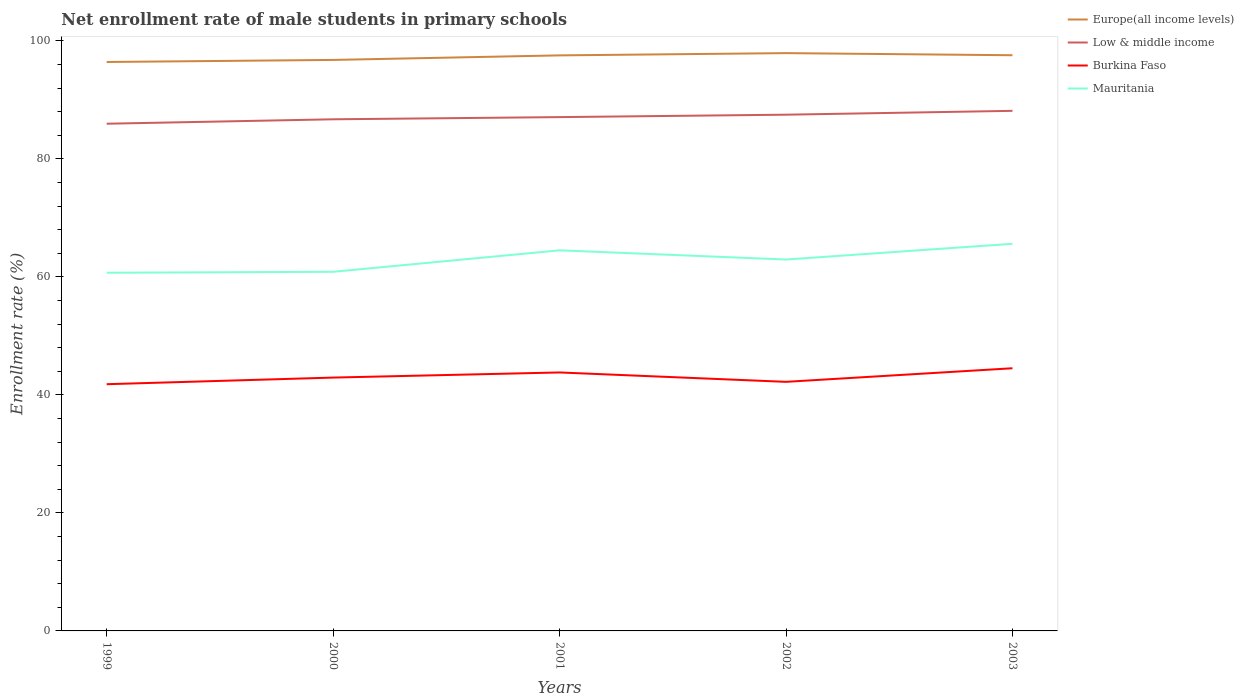Does the line corresponding to Mauritania intersect with the line corresponding to Low & middle income?
Your response must be concise. No. Is the number of lines equal to the number of legend labels?
Give a very brief answer. Yes. Across all years, what is the maximum net enrollment rate of male students in primary schools in Burkina Faso?
Your answer should be very brief. 41.81. What is the total net enrollment rate of male students in primary schools in Low & middle income in the graph?
Offer a terse response. -0.65. What is the difference between the highest and the second highest net enrollment rate of male students in primary schools in Mauritania?
Offer a very short reply. 4.91. What is the difference between two consecutive major ticks on the Y-axis?
Offer a very short reply. 20. Does the graph contain any zero values?
Your answer should be very brief. No. Where does the legend appear in the graph?
Your response must be concise. Top right. How are the legend labels stacked?
Make the answer very short. Vertical. What is the title of the graph?
Offer a very short reply. Net enrollment rate of male students in primary schools. Does "Fragile and conflict affected situations" appear as one of the legend labels in the graph?
Make the answer very short. No. What is the label or title of the X-axis?
Make the answer very short. Years. What is the label or title of the Y-axis?
Keep it short and to the point. Enrollment rate (%). What is the Enrollment rate (%) of Europe(all income levels) in 1999?
Your answer should be very brief. 96.42. What is the Enrollment rate (%) in Low & middle income in 1999?
Keep it short and to the point. 85.96. What is the Enrollment rate (%) in Burkina Faso in 1999?
Your response must be concise. 41.81. What is the Enrollment rate (%) of Mauritania in 1999?
Provide a short and direct response. 60.7. What is the Enrollment rate (%) of Europe(all income levels) in 2000?
Provide a succinct answer. 96.77. What is the Enrollment rate (%) of Low & middle income in 2000?
Provide a short and direct response. 86.71. What is the Enrollment rate (%) in Burkina Faso in 2000?
Offer a very short reply. 42.94. What is the Enrollment rate (%) in Mauritania in 2000?
Make the answer very short. 60.86. What is the Enrollment rate (%) of Europe(all income levels) in 2001?
Provide a short and direct response. 97.54. What is the Enrollment rate (%) in Low & middle income in 2001?
Provide a short and direct response. 87.08. What is the Enrollment rate (%) of Burkina Faso in 2001?
Your answer should be very brief. 43.8. What is the Enrollment rate (%) in Mauritania in 2001?
Make the answer very short. 64.5. What is the Enrollment rate (%) in Europe(all income levels) in 2002?
Your answer should be compact. 97.92. What is the Enrollment rate (%) of Low & middle income in 2002?
Provide a succinct answer. 87.49. What is the Enrollment rate (%) in Burkina Faso in 2002?
Keep it short and to the point. 42.21. What is the Enrollment rate (%) in Mauritania in 2002?
Offer a terse response. 62.94. What is the Enrollment rate (%) in Europe(all income levels) in 2003?
Provide a succinct answer. 97.56. What is the Enrollment rate (%) in Low & middle income in 2003?
Offer a very short reply. 88.14. What is the Enrollment rate (%) in Burkina Faso in 2003?
Your answer should be very brief. 44.52. What is the Enrollment rate (%) in Mauritania in 2003?
Provide a short and direct response. 65.61. Across all years, what is the maximum Enrollment rate (%) in Europe(all income levels)?
Keep it short and to the point. 97.92. Across all years, what is the maximum Enrollment rate (%) in Low & middle income?
Provide a succinct answer. 88.14. Across all years, what is the maximum Enrollment rate (%) in Burkina Faso?
Offer a very short reply. 44.52. Across all years, what is the maximum Enrollment rate (%) in Mauritania?
Ensure brevity in your answer.  65.61. Across all years, what is the minimum Enrollment rate (%) in Europe(all income levels)?
Your answer should be compact. 96.42. Across all years, what is the minimum Enrollment rate (%) in Low & middle income?
Provide a succinct answer. 85.96. Across all years, what is the minimum Enrollment rate (%) of Burkina Faso?
Provide a succinct answer. 41.81. Across all years, what is the minimum Enrollment rate (%) of Mauritania?
Your response must be concise. 60.7. What is the total Enrollment rate (%) of Europe(all income levels) in the graph?
Offer a very short reply. 486.22. What is the total Enrollment rate (%) of Low & middle income in the graph?
Your response must be concise. 435.37. What is the total Enrollment rate (%) of Burkina Faso in the graph?
Offer a terse response. 215.28. What is the total Enrollment rate (%) of Mauritania in the graph?
Ensure brevity in your answer.  314.62. What is the difference between the Enrollment rate (%) in Europe(all income levels) in 1999 and that in 2000?
Ensure brevity in your answer.  -0.35. What is the difference between the Enrollment rate (%) of Low & middle income in 1999 and that in 2000?
Offer a terse response. -0.75. What is the difference between the Enrollment rate (%) of Burkina Faso in 1999 and that in 2000?
Ensure brevity in your answer.  -1.12. What is the difference between the Enrollment rate (%) in Mauritania in 1999 and that in 2000?
Provide a succinct answer. -0.16. What is the difference between the Enrollment rate (%) in Europe(all income levels) in 1999 and that in 2001?
Offer a terse response. -1.12. What is the difference between the Enrollment rate (%) in Low & middle income in 1999 and that in 2001?
Make the answer very short. -1.12. What is the difference between the Enrollment rate (%) of Burkina Faso in 1999 and that in 2001?
Ensure brevity in your answer.  -1.99. What is the difference between the Enrollment rate (%) in Mauritania in 1999 and that in 2001?
Your answer should be compact. -3.8. What is the difference between the Enrollment rate (%) in Europe(all income levels) in 1999 and that in 2002?
Your response must be concise. -1.5. What is the difference between the Enrollment rate (%) of Low & middle income in 1999 and that in 2002?
Offer a terse response. -1.53. What is the difference between the Enrollment rate (%) in Burkina Faso in 1999 and that in 2002?
Offer a terse response. -0.4. What is the difference between the Enrollment rate (%) of Mauritania in 1999 and that in 2002?
Offer a very short reply. -2.24. What is the difference between the Enrollment rate (%) of Europe(all income levels) in 1999 and that in 2003?
Offer a terse response. -1.14. What is the difference between the Enrollment rate (%) in Low & middle income in 1999 and that in 2003?
Provide a succinct answer. -2.18. What is the difference between the Enrollment rate (%) in Burkina Faso in 1999 and that in 2003?
Provide a short and direct response. -2.7. What is the difference between the Enrollment rate (%) of Mauritania in 1999 and that in 2003?
Keep it short and to the point. -4.91. What is the difference between the Enrollment rate (%) in Europe(all income levels) in 2000 and that in 2001?
Offer a very short reply. -0.77. What is the difference between the Enrollment rate (%) in Low & middle income in 2000 and that in 2001?
Offer a very short reply. -0.37. What is the difference between the Enrollment rate (%) in Burkina Faso in 2000 and that in 2001?
Give a very brief answer. -0.87. What is the difference between the Enrollment rate (%) of Mauritania in 2000 and that in 2001?
Keep it short and to the point. -3.64. What is the difference between the Enrollment rate (%) of Europe(all income levels) in 2000 and that in 2002?
Give a very brief answer. -1.15. What is the difference between the Enrollment rate (%) in Low & middle income in 2000 and that in 2002?
Provide a succinct answer. -0.78. What is the difference between the Enrollment rate (%) of Burkina Faso in 2000 and that in 2002?
Ensure brevity in your answer.  0.72. What is the difference between the Enrollment rate (%) of Mauritania in 2000 and that in 2002?
Give a very brief answer. -2.08. What is the difference between the Enrollment rate (%) in Europe(all income levels) in 2000 and that in 2003?
Ensure brevity in your answer.  -0.79. What is the difference between the Enrollment rate (%) of Low & middle income in 2000 and that in 2003?
Provide a short and direct response. -1.43. What is the difference between the Enrollment rate (%) in Burkina Faso in 2000 and that in 2003?
Provide a short and direct response. -1.58. What is the difference between the Enrollment rate (%) of Mauritania in 2000 and that in 2003?
Your response must be concise. -4.75. What is the difference between the Enrollment rate (%) in Europe(all income levels) in 2001 and that in 2002?
Your response must be concise. -0.38. What is the difference between the Enrollment rate (%) of Low & middle income in 2001 and that in 2002?
Keep it short and to the point. -0.41. What is the difference between the Enrollment rate (%) in Burkina Faso in 2001 and that in 2002?
Your answer should be very brief. 1.59. What is the difference between the Enrollment rate (%) in Mauritania in 2001 and that in 2002?
Make the answer very short. 1.56. What is the difference between the Enrollment rate (%) in Europe(all income levels) in 2001 and that in 2003?
Your response must be concise. -0.02. What is the difference between the Enrollment rate (%) of Low & middle income in 2001 and that in 2003?
Your answer should be compact. -1.06. What is the difference between the Enrollment rate (%) in Burkina Faso in 2001 and that in 2003?
Offer a very short reply. -0.71. What is the difference between the Enrollment rate (%) of Mauritania in 2001 and that in 2003?
Keep it short and to the point. -1.11. What is the difference between the Enrollment rate (%) of Europe(all income levels) in 2002 and that in 2003?
Provide a short and direct response. 0.36. What is the difference between the Enrollment rate (%) in Low & middle income in 2002 and that in 2003?
Your answer should be very brief. -0.65. What is the difference between the Enrollment rate (%) of Burkina Faso in 2002 and that in 2003?
Offer a terse response. -2.3. What is the difference between the Enrollment rate (%) of Mauritania in 2002 and that in 2003?
Provide a succinct answer. -2.67. What is the difference between the Enrollment rate (%) of Europe(all income levels) in 1999 and the Enrollment rate (%) of Low & middle income in 2000?
Offer a very short reply. 9.71. What is the difference between the Enrollment rate (%) in Europe(all income levels) in 1999 and the Enrollment rate (%) in Burkina Faso in 2000?
Make the answer very short. 53.49. What is the difference between the Enrollment rate (%) of Europe(all income levels) in 1999 and the Enrollment rate (%) of Mauritania in 2000?
Provide a short and direct response. 35.56. What is the difference between the Enrollment rate (%) in Low & middle income in 1999 and the Enrollment rate (%) in Burkina Faso in 2000?
Offer a very short reply. 43.02. What is the difference between the Enrollment rate (%) in Low & middle income in 1999 and the Enrollment rate (%) in Mauritania in 2000?
Your response must be concise. 25.1. What is the difference between the Enrollment rate (%) of Burkina Faso in 1999 and the Enrollment rate (%) of Mauritania in 2000?
Keep it short and to the point. -19.05. What is the difference between the Enrollment rate (%) in Europe(all income levels) in 1999 and the Enrollment rate (%) in Low & middle income in 2001?
Provide a succinct answer. 9.34. What is the difference between the Enrollment rate (%) in Europe(all income levels) in 1999 and the Enrollment rate (%) in Burkina Faso in 2001?
Make the answer very short. 52.62. What is the difference between the Enrollment rate (%) of Europe(all income levels) in 1999 and the Enrollment rate (%) of Mauritania in 2001?
Provide a short and direct response. 31.92. What is the difference between the Enrollment rate (%) in Low & middle income in 1999 and the Enrollment rate (%) in Burkina Faso in 2001?
Offer a very short reply. 42.15. What is the difference between the Enrollment rate (%) of Low & middle income in 1999 and the Enrollment rate (%) of Mauritania in 2001?
Your answer should be very brief. 21.46. What is the difference between the Enrollment rate (%) of Burkina Faso in 1999 and the Enrollment rate (%) of Mauritania in 2001?
Offer a terse response. -22.69. What is the difference between the Enrollment rate (%) of Europe(all income levels) in 1999 and the Enrollment rate (%) of Low & middle income in 2002?
Ensure brevity in your answer.  8.93. What is the difference between the Enrollment rate (%) of Europe(all income levels) in 1999 and the Enrollment rate (%) of Burkina Faso in 2002?
Give a very brief answer. 54.21. What is the difference between the Enrollment rate (%) of Europe(all income levels) in 1999 and the Enrollment rate (%) of Mauritania in 2002?
Make the answer very short. 33.48. What is the difference between the Enrollment rate (%) of Low & middle income in 1999 and the Enrollment rate (%) of Burkina Faso in 2002?
Make the answer very short. 43.74. What is the difference between the Enrollment rate (%) of Low & middle income in 1999 and the Enrollment rate (%) of Mauritania in 2002?
Keep it short and to the point. 23.02. What is the difference between the Enrollment rate (%) of Burkina Faso in 1999 and the Enrollment rate (%) of Mauritania in 2002?
Your response must be concise. -21.13. What is the difference between the Enrollment rate (%) in Europe(all income levels) in 1999 and the Enrollment rate (%) in Low & middle income in 2003?
Give a very brief answer. 8.28. What is the difference between the Enrollment rate (%) of Europe(all income levels) in 1999 and the Enrollment rate (%) of Burkina Faso in 2003?
Ensure brevity in your answer.  51.91. What is the difference between the Enrollment rate (%) of Europe(all income levels) in 1999 and the Enrollment rate (%) of Mauritania in 2003?
Offer a very short reply. 30.81. What is the difference between the Enrollment rate (%) of Low & middle income in 1999 and the Enrollment rate (%) of Burkina Faso in 2003?
Keep it short and to the point. 41.44. What is the difference between the Enrollment rate (%) of Low & middle income in 1999 and the Enrollment rate (%) of Mauritania in 2003?
Offer a very short reply. 20.35. What is the difference between the Enrollment rate (%) of Burkina Faso in 1999 and the Enrollment rate (%) of Mauritania in 2003?
Keep it short and to the point. -23.8. What is the difference between the Enrollment rate (%) in Europe(all income levels) in 2000 and the Enrollment rate (%) in Low & middle income in 2001?
Ensure brevity in your answer.  9.69. What is the difference between the Enrollment rate (%) of Europe(all income levels) in 2000 and the Enrollment rate (%) of Burkina Faso in 2001?
Your answer should be very brief. 52.97. What is the difference between the Enrollment rate (%) in Europe(all income levels) in 2000 and the Enrollment rate (%) in Mauritania in 2001?
Offer a terse response. 32.27. What is the difference between the Enrollment rate (%) of Low & middle income in 2000 and the Enrollment rate (%) of Burkina Faso in 2001?
Provide a succinct answer. 42.9. What is the difference between the Enrollment rate (%) of Low & middle income in 2000 and the Enrollment rate (%) of Mauritania in 2001?
Ensure brevity in your answer.  22.21. What is the difference between the Enrollment rate (%) in Burkina Faso in 2000 and the Enrollment rate (%) in Mauritania in 2001?
Your response must be concise. -21.56. What is the difference between the Enrollment rate (%) of Europe(all income levels) in 2000 and the Enrollment rate (%) of Low & middle income in 2002?
Give a very brief answer. 9.28. What is the difference between the Enrollment rate (%) of Europe(all income levels) in 2000 and the Enrollment rate (%) of Burkina Faso in 2002?
Your answer should be very brief. 54.56. What is the difference between the Enrollment rate (%) of Europe(all income levels) in 2000 and the Enrollment rate (%) of Mauritania in 2002?
Offer a terse response. 33.83. What is the difference between the Enrollment rate (%) of Low & middle income in 2000 and the Enrollment rate (%) of Burkina Faso in 2002?
Provide a succinct answer. 44.49. What is the difference between the Enrollment rate (%) of Low & middle income in 2000 and the Enrollment rate (%) of Mauritania in 2002?
Offer a very short reply. 23.76. What is the difference between the Enrollment rate (%) of Burkina Faso in 2000 and the Enrollment rate (%) of Mauritania in 2002?
Provide a succinct answer. -20.01. What is the difference between the Enrollment rate (%) in Europe(all income levels) in 2000 and the Enrollment rate (%) in Low & middle income in 2003?
Keep it short and to the point. 8.63. What is the difference between the Enrollment rate (%) in Europe(all income levels) in 2000 and the Enrollment rate (%) in Burkina Faso in 2003?
Offer a terse response. 52.25. What is the difference between the Enrollment rate (%) in Europe(all income levels) in 2000 and the Enrollment rate (%) in Mauritania in 2003?
Provide a succinct answer. 31.16. What is the difference between the Enrollment rate (%) of Low & middle income in 2000 and the Enrollment rate (%) of Burkina Faso in 2003?
Keep it short and to the point. 42.19. What is the difference between the Enrollment rate (%) of Low & middle income in 2000 and the Enrollment rate (%) of Mauritania in 2003?
Give a very brief answer. 21.1. What is the difference between the Enrollment rate (%) in Burkina Faso in 2000 and the Enrollment rate (%) in Mauritania in 2003?
Your answer should be very brief. -22.68. What is the difference between the Enrollment rate (%) in Europe(all income levels) in 2001 and the Enrollment rate (%) in Low & middle income in 2002?
Your answer should be very brief. 10.05. What is the difference between the Enrollment rate (%) in Europe(all income levels) in 2001 and the Enrollment rate (%) in Burkina Faso in 2002?
Provide a succinct answer. 55.33. What is the difference between the Enrollment rate (%) in Europe(all income levels) in 2001 and the Enrollment rate (%) in Mauritania in 2002?
Give a very brief answer. 34.6. What is the difference between the Enrollment rate (%) in Low & middle income in 2001 and the Enrollment rate (%) in Burkina Faso in 2002?
Offer a terse response. 44.87. What is the difference between the Enrollment rate (%) in Low & middle income in 2001 and the Enrollment rate (%) in Mauritania in 2002?
Keep it short and to the point. 24.14. What is the difference between the Enrollment rate (%) of Burkina Faso in 2001 and the Enrollment rate (%) of Mauritania in 2002?
Ensure brevity in your answer.  -19.14. What is the difference between the Enrollment rate (%) in Europe(all income levels) in 2001 and the Enrollment rate (%) in Low & middle income in 2003?
Your response must be concise. 9.4. What is the difference between the Enrollment rate (%) in Europe(all income levels) in 2001 and the Enrollment rate (%) in Burkina Faso in 2003?
Give a very brief answer. 53.03. What is the difference between the Enrollment rate (%) in Europe(all income levels) in 2001 and the Enrollment rate (%) in Mauritania in 2003?
Your answer should be compact. 31.93. What is the difference between the Enrollment rate (%) in Low & middle income in 2001 and the Enrollment rate (%) in Burkina Faso in 2003?
Provide a succinct answer. 42.56. What is the difference between the Enrollment rate (%) of Low & middle income in 2001 and the Enrollment rate (%) of Mauritania in 2003?
Keep it short and to the point. 21.47. What is the difference between the Enrollment rate (%) in Burkina Faso in 2001 and the Enrollment rate (%) in Mauritania in 2003?
Provide a short and direct response. -21.81. What is the difference between the Enrollment rate (%) of Europe(all income levels) in 2002 and the Enrollment rate (%) of Low & middle income in 2003?
Give a very brief answer. 9.78. What is the difference between the Enrollment rate (%) of Europe(all income levels) in 2002 and the Enrollment rate (%) of Burkina Faso in 2003?
Your response must be concise. 53.41. What is the difference between the Enrollment rate (%) of Europe(all income levels) in 2002 and the Enrollment rate (%) of Mauritania in 2003?
Provide a short and direct response. 32.31. What is the difference between the Enrollment rate (%) of Low & middle income in 2002 and the Enrollment rate (%) of Burkina Faso in 2003?
Provide a succinct answer. 42.97. What is the difference between the Enrollment rate (%) of Low & middle income in 2002 and the Enrollment rate (%) of Mauritania in 2003?
Your response must be concise. 21.88. What is the difference between the Enrollment rate (%) in Burkina Faso in 2002 and the Enrollment rate (%) in Mauritania in 2003?
Offer a very short reply. -23.4. What is the average Enrollment rate (%) in Europe(all income levels) per year?
Your response must be concise. 97.24. What is the average Enrollment rate (%) of Low & middle income per year?
Provide a short and direct response. 87.07. What is the average Enrollment rate (%) in Burkina Faso per year?
Your answer should be very brief. 43.06. What is the average Enrollment rate (%) of Mauritania per year?
Keep it short and to the point. 62.92. In the year 1999, what is the difference between the Enrollment rate (%) in Europe(all income levels) and Enrollment rate (%) in Low & middle income?
Offer a terse response. 10.46. In the year 1999, what is the difference between the Enrollment rate (%) of Europe(all income levels) and Enrollment rate (%) of Burkina Faso?
Your answer should be very brief. 54.61. In the year 1999, what is the difference between the Enrollment rate (%) of Europe(all income levels) and Enrollment rate (%) of Mauritania?
Your response must be concise. 35.72. In the year 1999, what is the difference between the Enrollment rate (%) in Low & middle income and Enrollment rate (%) in Burkina Faso?
Your answer should be very brief. 44.14. In the year 1999, what is the difference between the Enrollment rate (%) in Low & middle income and Enrollment rate (%) in Mauritania?
Your answer should be very brief. 25.25. In the year 1999, what is the difference between the Enrollment rate (%) of Burkina Faso and Enrollment rate (%) of Mauritania?
Provide a short and direct response. -18.89. In the year 2000, what is the difference between the Enrollment rate (%) of Europe(all income levels) and Enrollment rate (%) of Low & middle income?
Your response must be concise. 10.06. In the year 2000, what is the difference between the Enrollment rate (%) of Europe(all income levels) and Enrollment rate (%) of Burkina Faso?
Provide a short and direct response. 53.83. In the year 2000, what is the difference between the Enrollment rate (%) of Europe(all income levels) and Enrollment rate (%) of Mauritania?
Your response must be concise. 35.91. In the year 2000, what is the difference between the Enrollment rate (%) of Low & middle income and Enrollment rate (%) of Burkina Faso?
Keep it short and to the point. 43.77. In the year 2000, what is the difference between the Enrollment rate (%) in Low & middle income and Enrollment rate (%) in Mauritania?
Give a very brief answer. 25.84. In the year 2000, what is the difference between the Enrollment rate (%) of Burkina Faso and Enrollment rate (%) of Mauritania?
Your answer should be very brief. -17.93. In the year 2001, what is the difference between the Enrollment rate (%) of Europe(all income levels) and Enrollment rate (%) of Low & middle income?
Your answer should be very brief. 10.46. In the year 2001, what is the difference between the Enrollment rate (%) in Europe(all income levels) and Enrollment rate (%) in Burkina Faso?
Give a very brief answer. 53.74. In the year 2001, what is the difference between the Enrollment rate (%) in Europe(all income levels) and Enrollment rate (%) in Mauritania?
Your answer should be very brief. 33.04. In the year 2001, what is the difference between the Enrollment rate (%) of Low & middle income and Enrollment rate (%) of Burkina Faso?
Your response must be concise. 43.27. In the year 2001, what is the difference between the Enrollment rate (%) in Low & middle income and Enrollment rate (%) in Mauritania?
Give a very brief answer. 22.58. In the year 2001, what is the difference between the Enrollment rate (%) of Burkina Faso and Enrollment rate (%) of Mauritania?
Keep it short and to the point. -20.7. In the year 2002, what is the difference between the Enrollment rate (%) of Europe(all income levels) and Enrollment rate (%) of Low & middle income?
Offer a very short reply. 10.43. In the year 2002, what is the difference between the Enrollment rate (%) in Europe(all income levels) and Enrollment rate (%) in Burkina Faso?
Provide a succinct answer. 55.71. In the year 2002, what is the difference between the Enrollment rate (%) in Europe(all income levels) and Enrollment rate (%) in Mauritania?
Provide a succinct answer. 34.98. In the year 2002, what is the difference between the Enrollment rate (%) in Low & middle income and Enrollment rate (%) in Burkina Faso?
Ensure brevity in your answer.  45.27. In the year 2002, what is the difference between the Enrollment rate (%) in Low & middle income and Enrollment rate (%) in Mauritania?
Make the answer very short. 24.55. In the year 2002, what is the difference between the Enrollment rate (%) in Burkina Faso and Enrollment rate (%) in Mauritania?
Provide a succinct answer. -20.73. In the year 2003, what is the difference between the Enrollment rate (%) in Europe(all income levels) and Enrollment rate (%) in Low & middle income?
Provide a succinct answer. 9.42. In the year 2003, what is the difference between the Enrollment rate (%) of Europe(all income levels) and Enrollment rate (%) of Burkina Faso?
Provide a succinct answer. 53.05. In the year 2003, what is the difference between the Enrollment rate (%) in Europe(all income levels) and Enrollment rate (%) in Mauritania?
Give a very brief answer. 31.95. In the year 2003, what is the difference between the Enrollment rate (%) in Low & middle income and Enrollment rate (%) in Burkina Faso?
Make the answer very short. 43.63. In the year 2003, what is the difference between the Enrollment rate (%) in Low & middle income and Enrollment rate (%) in Mauritania?
Offer a very short reply. 22.53. In the year 2003, what is the difference between the Enrollment rate (%) in Burkina Faso and Enrollment rate (%) in Mauritania?
Offer a terse response. -21.09. What is the ratio of the Enrollment rate (%) in Low & middle income in 1999 to that in 2000?
Ensure brevity in your answer.  0.99. What is the ratio of the Enrollment rate (%) of Burkina Faso in 1999 to that in 2000?
Provide a succinct answer. 0.97. What is the ratio of the Enrollment rate (%) in Europe(all income levels) in 1999 to that in 2001?
Keep it short and to the point. 0.99. What is the ratio of the Enrollment rate (%) in Low & middle income in 1999 to that in 2001?
Ensure brevity in your answer.  0.99. What is the ratio of the Enrollment rate (%) in Burkina Faso in 1999 to that in 2001?
Offer a very short reply. 0.95. What is the ratio of the Enrollment rate (%) in Mauritania in 1999 to that in 2001?
Your answer should be compact. 0.94. What is the ratio of the Enrollment rate (%) of Europe(all income levels) in 1999 to that in 2002?
Keep it short and to the point. 0.98. What is the ratio of the Enrollment rate (%) of Low & middle income in 1999 to that in 2002?
Offer a very short reply. 0.98. What is the ratio of the Enrollment rate (%) of Mauritania in 1999 to that in 2002?
Your answer should be compact. 0.96. What is the ratio of the Enrollment rate (%) in Europe(all income levels) in 1999 to that in 2003?
Offer a terse response. 0.99. What is the ratio of the Enrollment rate (%) of Low & middle income in 1999 to that in 2003?
Make the answer very short. 0.98. What is the ratio of the Enrollment rate (%) of Burkina Faso in 1999 to that in 2003?
Your response must be concise. 0.94. What is the ratio of the Enrollment rate (%) in Mauritania in 1999 to that in 2003?
Provide a succinct answer. 0.93. What is the ratio of the Enrollment rate (%) of Low & middle income in 2000 to that in 2001?
Give a very brief answer. 1. What is the ratio of the Enrollment rate (%) in Burkina Faso in 2000 to that in 2001?
Offer a very short reply. 0.98. What is the ratio of the Enrollment rate (%) of Mauritania in 2000 to that in 2001?
Your answer should be compact. 0.94. What is the ratio of the Enrollment rate (%) in Burkina Faso in 2000 to that in 2002?
Provide a short and direct response. 1.02. What is the ratio of the Enrollment rate (%) of Europe(all income levels) in 2000 to that in 2003?
Offer a terse response. 0.99. What is the ratio of the Enrollment rate (%) of Low & middle income in 2000 to that in 2003?
Make the answer very short. 0.98. What is the ratio of the Enrollment rate (%) in Burkina Faso in 2000 to that in 2003?
Make the answer very short. 0.96. What is the ratio of the Enrollment rate (%) in Mauritania in 2000 to that in 2003?
Provide a short and direct response. 0.93. What is the ratio of the Enrollment rate (%) in Burkina Faso in 2001 to that in 2002?
Your answer should be compact. 1.04. What is the ratio of the Enrollment rate (%) of Mauritania in 2001 to that in 2002?
Give a very brief answer. 1.02. What is the ratio of the Enrollment rate (%) in Low & middle income in 2001 to that in 2003?
Your response must be concise. 0.99. What is the ratio of the Enrollment rate (%) in Mauritania in 2001 to that in 2003?
Keep it short and to the point. 0.98. What is the ratio of the Enrollment rate (%) in Europe(all income levels) in 2002 to that in 2003?
Provide a succinct answer. 1. What is the ratio of the Enrollment rate (%) of Low & middle income in 2002 to that in 2003?
Give a very brief answer. 0.99. What is the ratio of the Enrollment rate (%) in Burkina Faso in 2002 to that in 2003?
Offer a terse response. 0.95. What is the ratio of the Enrollment rate (%) of Mauritania in 2002 to that in 2003?
Offer a very short reply. 0.96. What is the difference between the highest and the second highest Enrollment rate (%) in Europe(all income levels)?
Keep it short and to the point. 0.36. What is the difference between the highest and the second highest Enrollment rate (%) in Low & middle income?
Keep it short and to the point. 0.65. What is the difference between the highest and the second highest Enrollment rate (%) in Burkina Faso?
Your response must be concise. 0.71. What is the difference between the highest and the second highest Enrollment rate (%) of Mauritania?
Your answer should be compact. 1.11. What is the difference between the highest and the lowest Enrollment rate (%) in Europe(all income levels)?
Your answer should be compact. 1.5. What is the difference between the highest and the lowest Enrollment rate (%) in Low & middle income?
Give a very brief answer. 2.18. What is the difference between the highest and the lowest Enrollment rate (%) in Burkina Faso?
Give a very brief answer. 2.7. What is the difference between the highest and the lowest Enrollment rate (%) of Mauritania?
Offer a terse response. 4.91. 